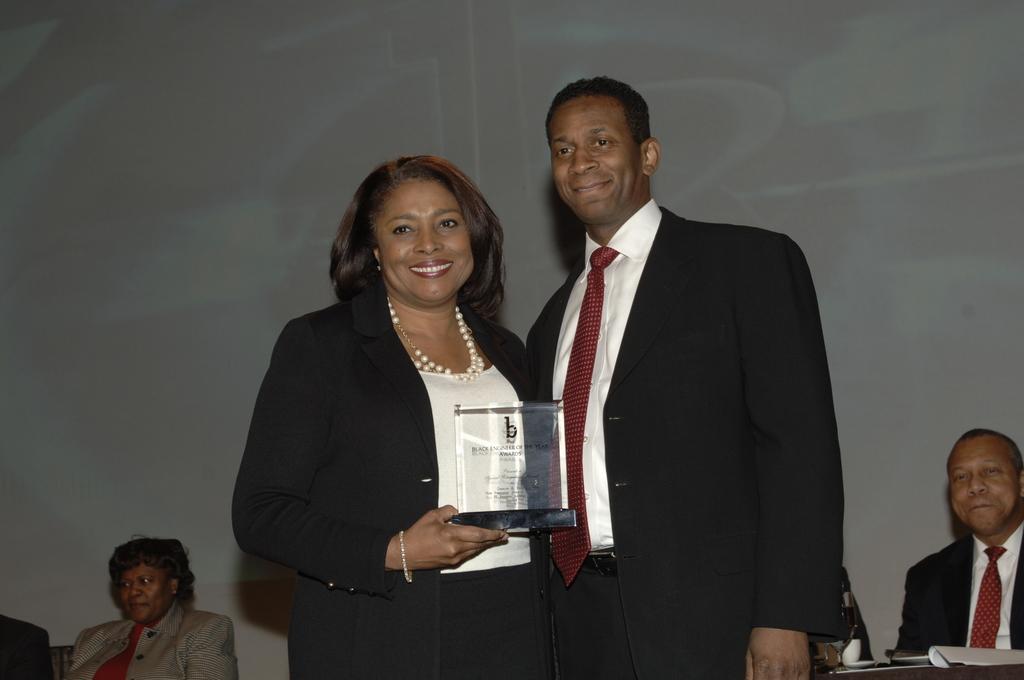Can you describe this image briefly? In this image I can see a woman and a man wearing white and black colored dresses are standing. I can see a woman is holding an object in her hand. In the background I can see few persons sitting and a huge screen. 